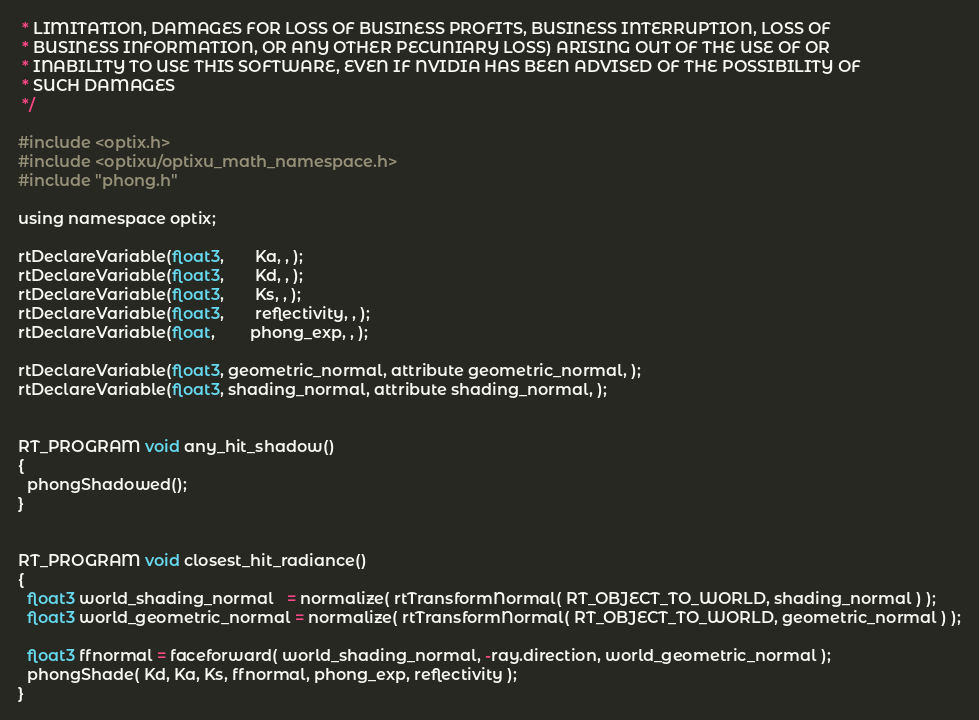Convert code to text. <code><loc_0><loc_0><loc_500><loc_500><_Cuda_> * LIMITATION, DAMAGES FOR LOSS OF BUSINESS PROFITS, BUSINESS INTERRUPTION, LOSS OF
 * BUSINESS INFORMATION, OR ANY OTHER PECUNIARY LOSS) ARISING OUT OF THE USE OF OR
 * INABILITY TO USE THIS SOFTWARE, EVEN IF NVIDIA HAS BEEN ADVISED OF THE POSSIBILITY OF
 * SUCH DAMAGES
 */

#include <optix.h>
#include <optixu/optixu_math_namespace.h>
#include "phong.h"

using namespace optix;

rtDeclareVariable(float3,       Ka, , );
rtDeclareVariable(float3,       Kd, , );
rtDeclareVariable(float3,       Ks, , );
rtDeclareVariable(float3,       reflectivity, , );
rtDeclareVariable(float,        phong_exp, , );

rtDeclareVariable(float3, geometric_normal, attribute geometric_normal, ); 
rtDeclareVariable(float3, shading_normal, attribute shading_normal, ); 


RT_PROGRAM void any_hit_shadow()
{
  phongShadowed();
}


RT_PROGRAM void closest_hit_radiance()
{
  float3 world_shading_normal   = normalize( rtTransformNormal( RT_OBJECT_TO_WORLD, shading_normal ) );
  float3 world_geometric_normal = normalize( rtTransformNormal( RT_OBJECT_TO_WORLD, geometric_normal ) );

  float3 ffnormal = faceforward( world_shading_normal, -ray.direction, world_geometric_normal );
  phongShade( Kd, Ka, Ks, ffnormal, phong_exp, reflectivity );
}
</code> 